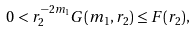Convert formula to latex. <formula><loc_0><loc_0><loc_500><loc_500>0 < r _ { 2 } ^ { - 2 m _ { 1 } } G ( m _ { 1 } , r _ { 2 } ) \leq F ( r _ { 2 } ) ,</formula> 